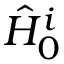Convert formula to latex. <formula><loc_0><loc_0><loc_500><loc_500>\hat { H } _ { 0 } ^ { i }</formula> 